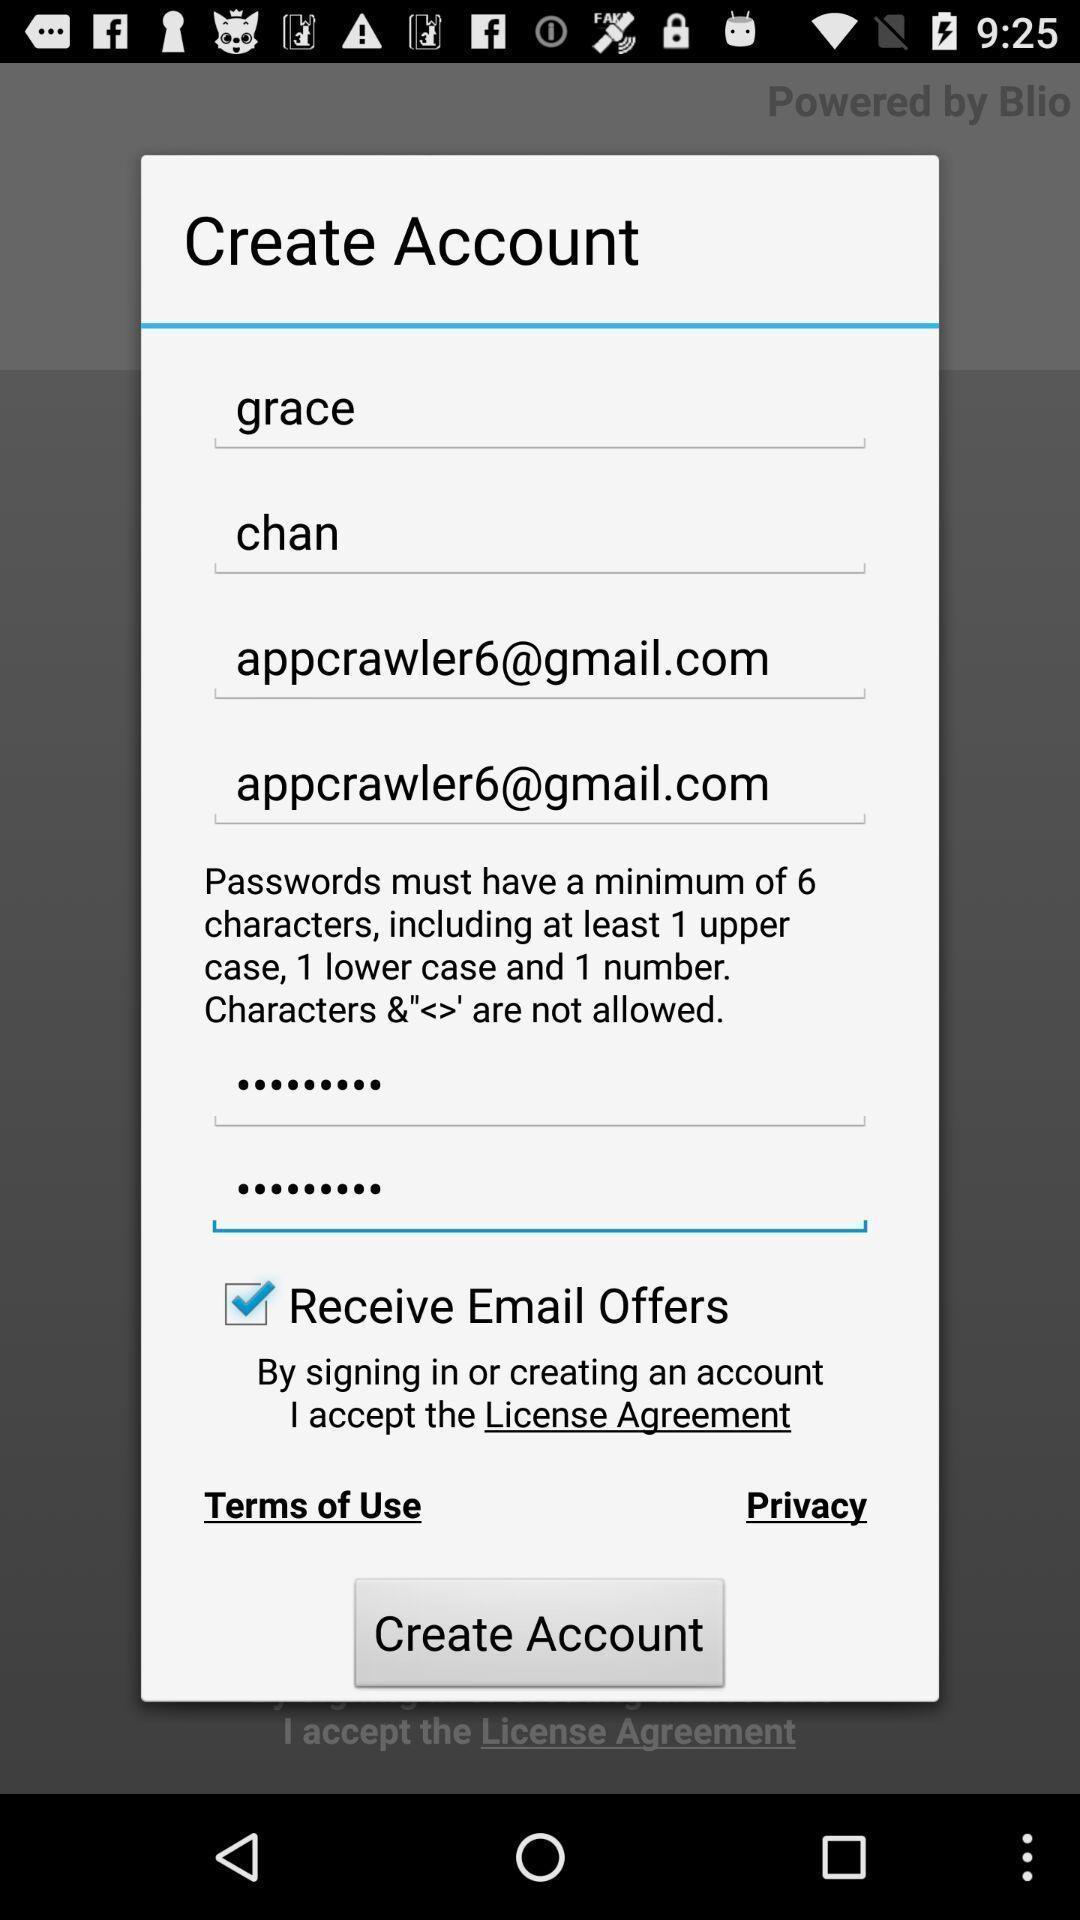Describe this image in words. Pop-up with account creation options. 